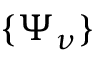<formula> <loc_0><loc_0><loc_500><loc_500>\{ \Psi _ { \nu } \}</formula> 